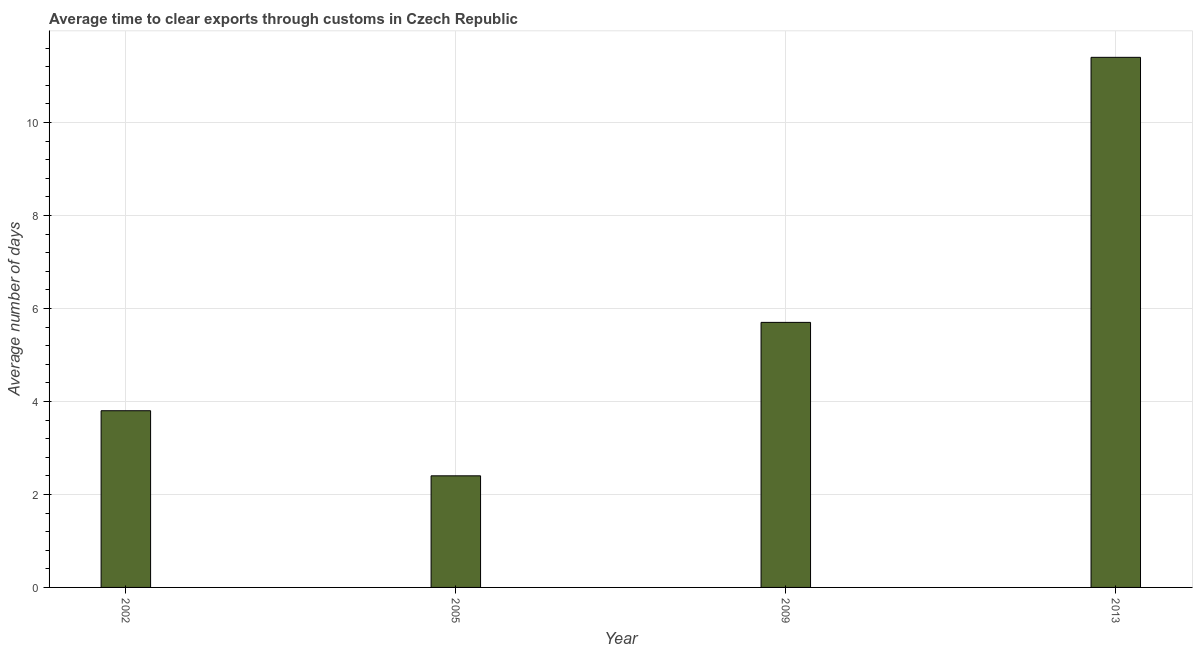Does the graph contain grids?
Keep it short and to the point. Yes. What is the title of the graph?
Offer a terse response. Average time to clear exports through customs in Czech Republic. What is the label or title of the X-axis?
Offer a very short reply. Year. What is the label or title of the Y-axis?
Offer a very short reply. Average number of days. What is the time to clear exports through customs in 2013?
Your answer should be very brief. 11.4. Across all years, what is the maximum time to clear exports through customs?
Provide a succinct answer. 11.4. In which year was the time to clear exports through customs maximum?
Your answer should be very brief. 2013. In which year was the time to clear exports through customs minimum?
Provide a short and direct response. 2005. What is the sum of the time to clear exports through customs?
Your response must be concise. 23.3. What is the average time to clear exports through customs per year?
Your response must be concise. 5.83. What is the median time to clear exports through customs?
Offer a very short reply. 4.75. Do a majority of the years between 2002 and 2005 (inclusive) have time to clear exports through customs greater than 4.8 days?
Your answer should be compact. No. What is the ratio of the time to clear exports through customs in 2002 to that in 2005?
Provide a succinct answer. 1.58. Is the difference between the time to clear exports through customs in 2002 and 2009 greater than the difference between any two years?
Give a very brief answer. No. Is the sum of the time to clear exports through customs in 2009 and 2013 greater than the maximum time to clear exports through customs across all years?
Your answer should be very brief. Yes. How many bars are there?
Your response must be concise. 4. Are all the bars in the graph horizontal?
Your response must be concise. No. What is the difference between two consecutive major ticks on the Y-axis?
Ensure brevity in your answer.  2. Are the values on the major ticks of Y-axis written in scientific E-notation?
Offer a terse response. No. What is the difference between the Average number of days in 2002 and 2009?
Your answer should be very brief. -1.9. What is the difference between the Average number of days in 2002 and 2013?
Your answer should be compact. -7.6. What is the difference between the Average number of days in 2005 and 2009?
Provide a short and direct response. -3.3. What is the difference between the Average number of days in 2005 and 2013?
Ensure brevity in your answer.  -9. What is the difference between the Average number of days in 2009 and 2013?
Give a very brief answer. -5.7. What is the ratio of the Average number of days in 2002 to that in 2005?
Offer a very short reply. 1.58. What is the ratio of the Average number of days in 2002 to that in 2009?
Offer a very short reply. 0.67. What is the ratio of the Average number of days in 2002 to that in 2013?
Give a very brief answer. 0.33. What is the ratio of the Average number of days in 2005 to that in 2009?
Provide a succinct answer. 0.42. What is the ratio of the Average number of days in 2005 to that in 2013?
Make the answer very short. 0.21. 